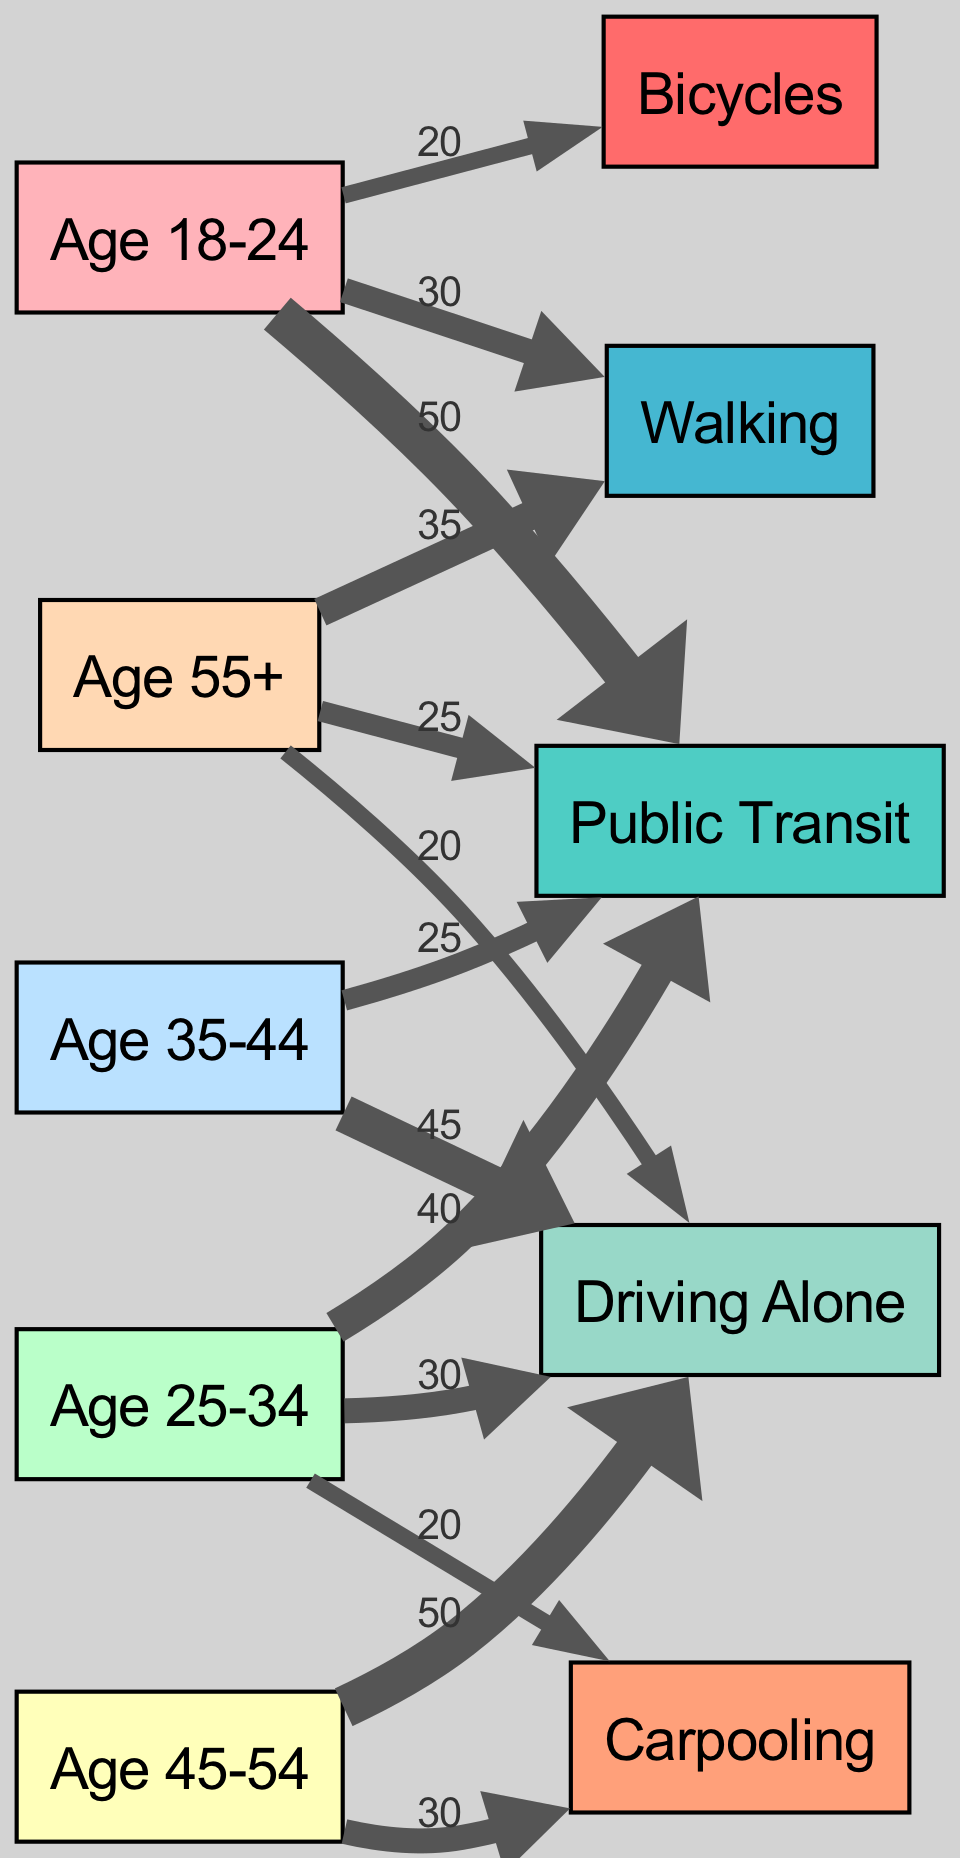What is the highest mode of transportation used by the age group 45-54? The diagram shows that the age group 45-54 has the most significant use of "Driving Alone" with a value of 50.
Answer: Driving Alone How many different age groups are represented in the diagram? There are five age groups represented in the diagram: Age 18-24, Age 25-34, Age 35-44, Age 45-54, and Age 55+.
Answer: 5 What is the total number of people using Public Transit from the age group 25-34? The diagram indicates that 40 people in the age group 25-34 use Public Transit, which is the only measurement for this age group related to this transport mode.
Answer: 40 Which age group has the least usage of Bicycles? By examining the flow for Bicycles, it's clear that no age group besides Age 18-24 uses it, meaning it's the least utilized since it shows a usage level of 0 for every other age group.
Answer: Age 25-34 What is the total value of Walking used by all age groups? Summing the values of Walking (30 from Age 18-24, and 35 from Age 55+) results in a total of 65, showing that it's a commonly used transportation mode among these specific age groups.
Answer: 65 Which mode of transportation is used equally by both Age 25-34 and Age 35-44 groups? By comparing these age groups' links, it's evident that they do not share any equal usage among modes of transport; hence, there isn't any mode that is used equally by both age groups.
Answer: None What is the value difference in driving alone between the age groups 35-44 and 45-54? The age group 35-44 has a driving alone value of 45, while the age group 45-54 has a value of 50. The difference between these two values is computed as 50 - 45, resulting in a difference of 5.
Answer: 5 Which mode of transportation is the least utilized overall in the diagram? By looking at the connections, it's clear that the lowest number of usages, aside from zero, occurs with Carpooling, especially in the age groups analyzed.
Answer: Carpooling What percentage of the total usage from the age group 18-24 is for Public Transit? To calculate this, sum up all transport usages from Age 18-24 (20 + 50 + 30 = 100) then find the usage for Public Transit (50), resulting in a percentage calculation as (50/100) * 100 = 50%.
Answer: 50% 